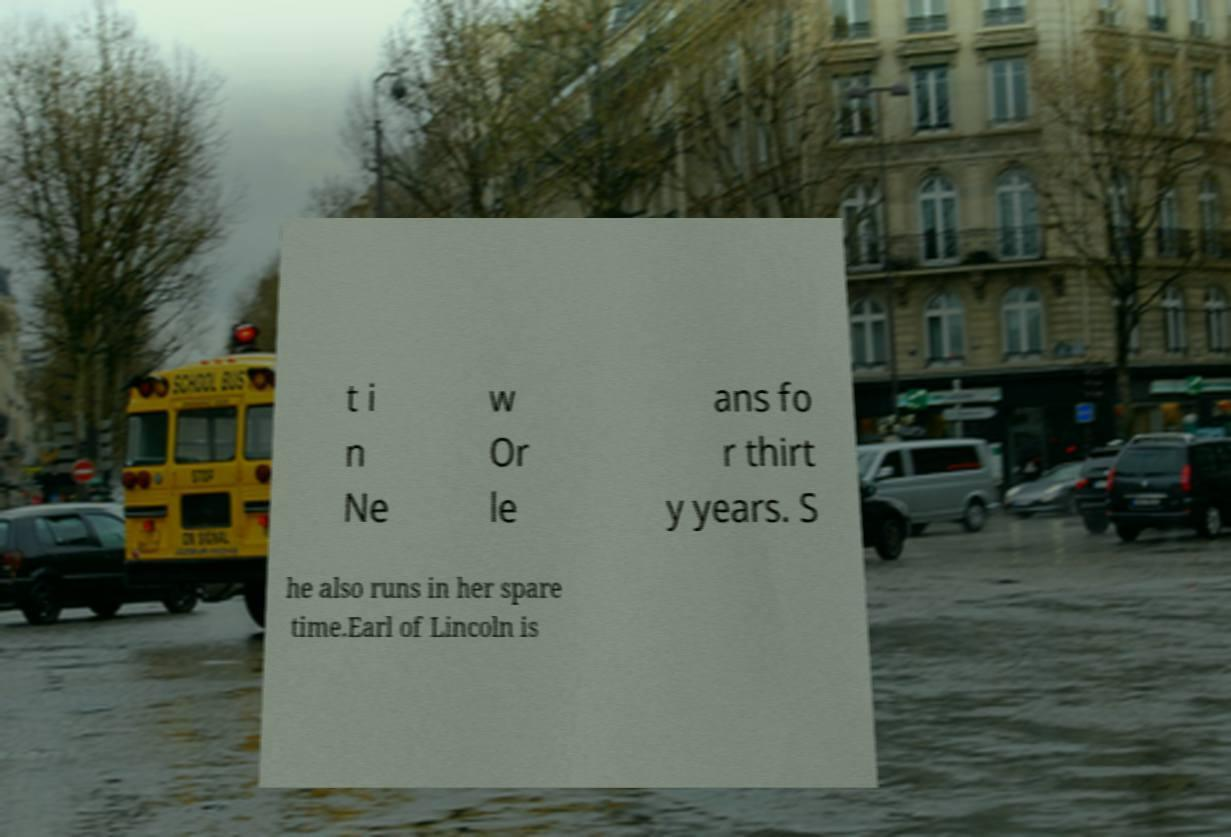What messages or text are displayed in this image? I need them in a readable, typed format. t i n Ne w Or le ans fo r thirt y years. S he also runs in her spare time.Earl of Lincoln is 